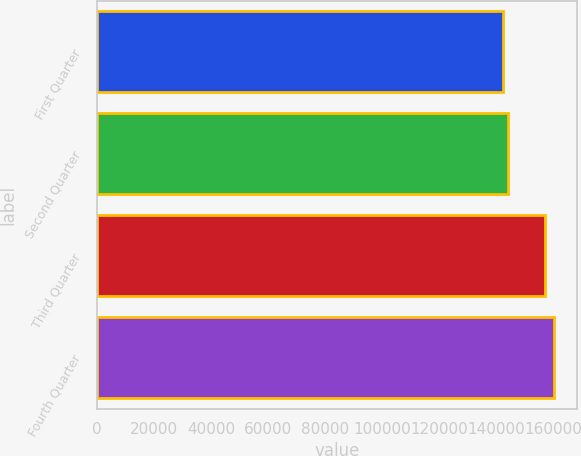<chart> <loc_0><loc_0><loc_500><loc_500><bar_chart><fcel>First Quarter<fcel>Second Quarter<fcel>Third Quarter<fcel>Fourth Quarter<nl><fcel>142330<fcel>144130<fcel>156930<fcel>160334<nl></chart> 